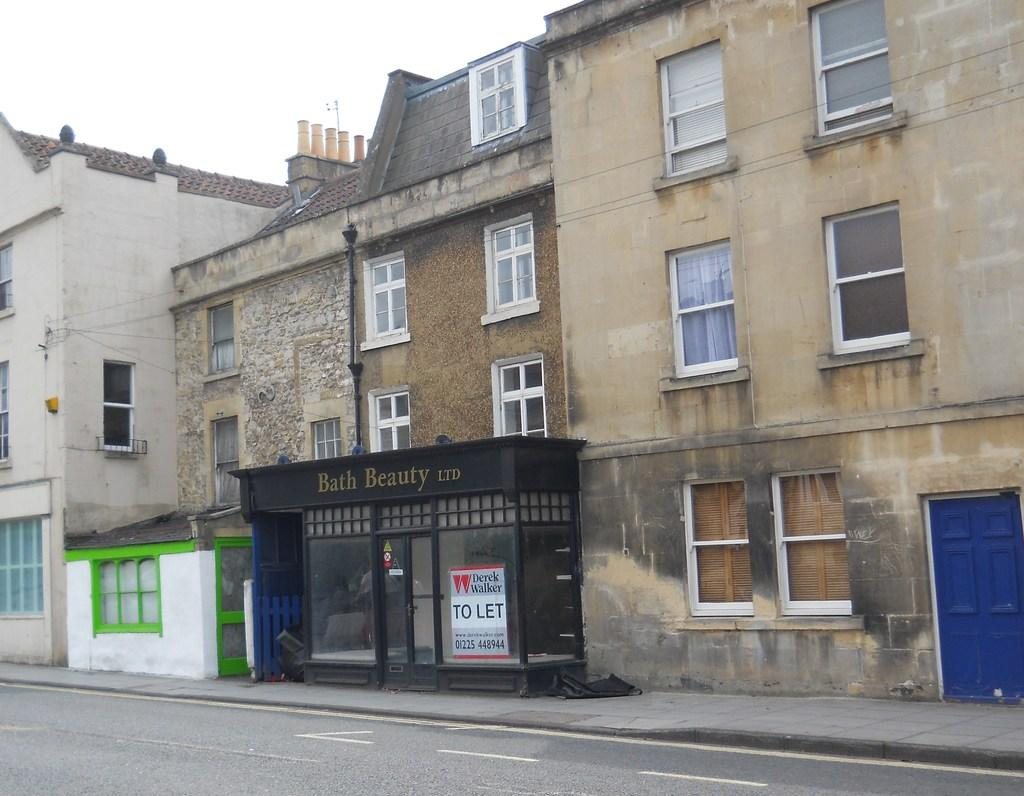What type of structures are present in the image? There are buildings in the image. What feature do the buildings have? The buildings have windows. Are there any additional elements on the buildings? Yes, there are advertising boards on the buildings. What can be seen at the bottom of the image? There is a road visible at the bottom of the image. What is visible at the top of the image? The sky is visible at the top of the image. What type of polish is being applied to the cord in the image? There is no polish or cord present in the image. What kind of pet can be seen interacting with the buildings in the image? There are no pets visible in the image; it only features buildings, windows, advertising boards, a road, and the sky. 